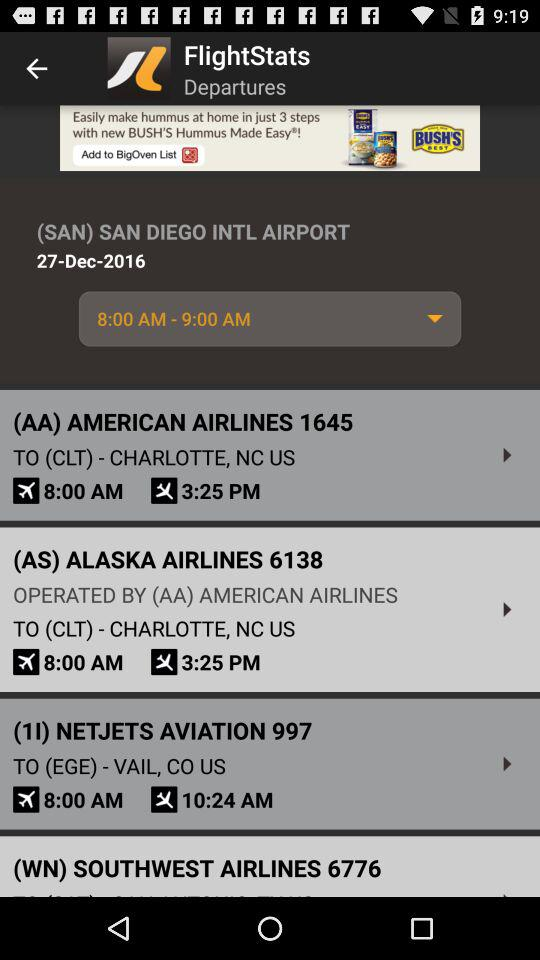What is the earliest departure time of all flights?
Answer the question using a single word or phrase. 8:00 AM 